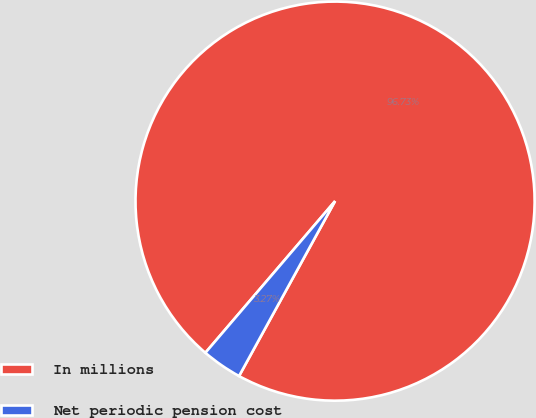Convert chart to OTSL. <chart><loc_0><loc_0><loc_500><loc_500><pie_chart><fcel>In millions<fcel>Net periodic pension cost<nl><fcel>96.73%<fcel>3.27%<nl></chart> 